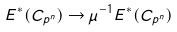<formula> <loc_0><loc_0><loc_500><loc_500>E ^ { * } ( C _ { p ^ { n } } ) \to \mu ^ { - 1 } E ^ { * } ( C _ { p ^ { n } } )</formula> 